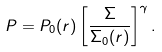Convert formula to latex. <formula><loc_0><loc_0><loc_500><loc_500>P = P _ { 0 } ( r ) \left [ \frac { \Sigma } { \Sigma _ { 0 } ( r ) } \right ] ^ { \gamma } .</formula> 